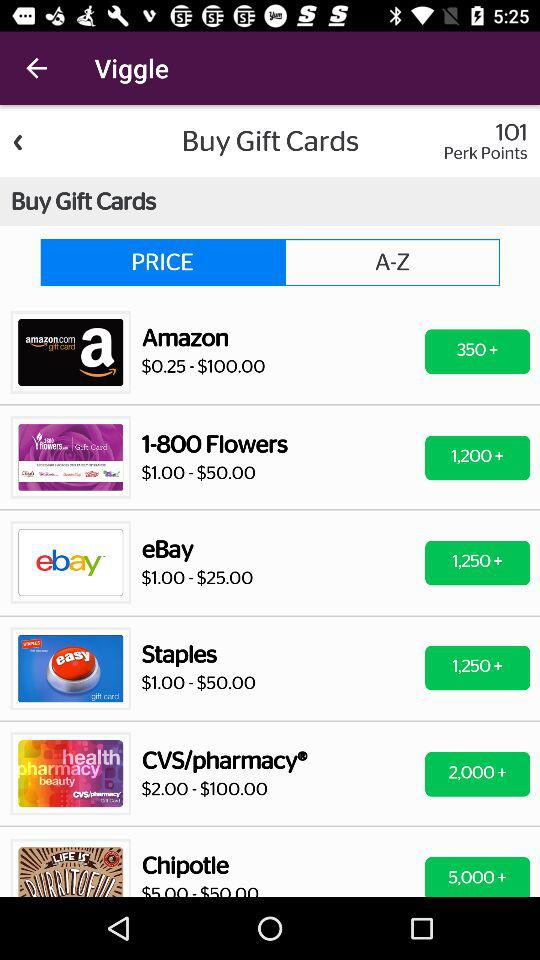How many gift cards are available under $100?
Answer the question using a single word or phrase. 6 